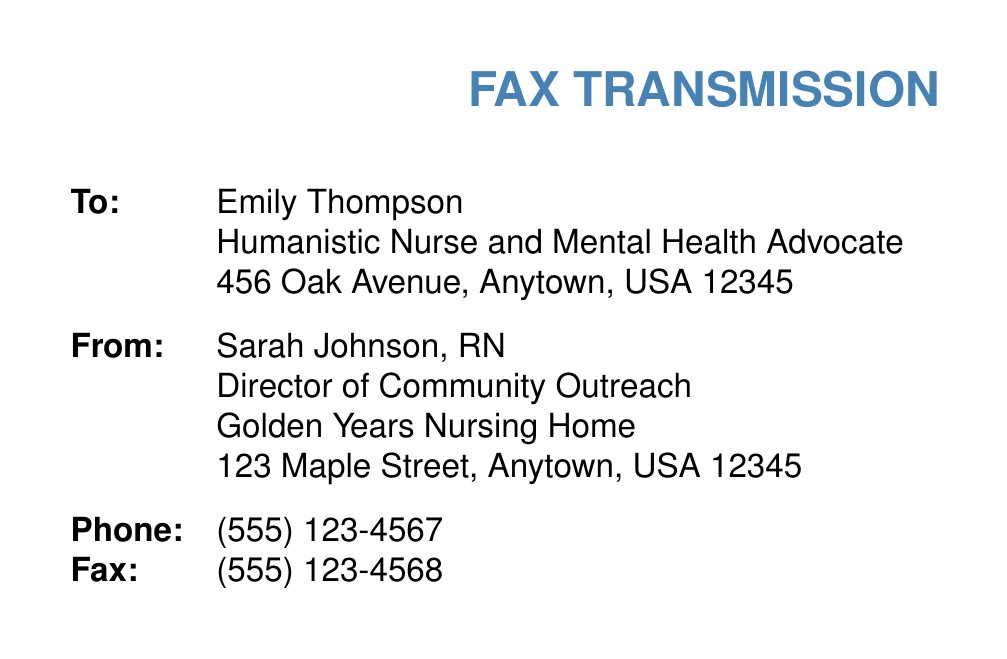What is the name of the nursing home? The nursing home mentioned in the document is Golden Years Nursing Home.
Answer: Golden Years Nursing Home Who is the speaker invited to the seminar? The speaker invited to the seminar is Emily Thompson.
Answer: Emily Thompson What is the date of the event? The date of the event is specified as June 15, 2023.
Answer: June 15, 2023 How long is the presentation? The length of the presentation is mentioned as 45 minutes.
Answer: 45 minutes What email should the RSVP be sent to? The RSVP should be sent to Sarah Johnson at sjohnson@goldenyears.org.
Answer: sjohnson@goldenyears.org What topic involves cognitive activities for daily practice? The document references simple cognitive activities for daily practice as one of the topics.
Answer: Simple cognitive activities for daily practice What equipment will be provided for the seminar? The equipment provided includes a projector, microphone, and whiteboard.
Answer: Projector, Microphone, Whiteboard How many minutes is the Q&A session? The duration of the Q&A session is indicated as 15 minutes.
Answer: 15 minutes What time does the seminar start? The start time of the seminar is stated as 2:00 PM.
Answer: 2:00 PM 